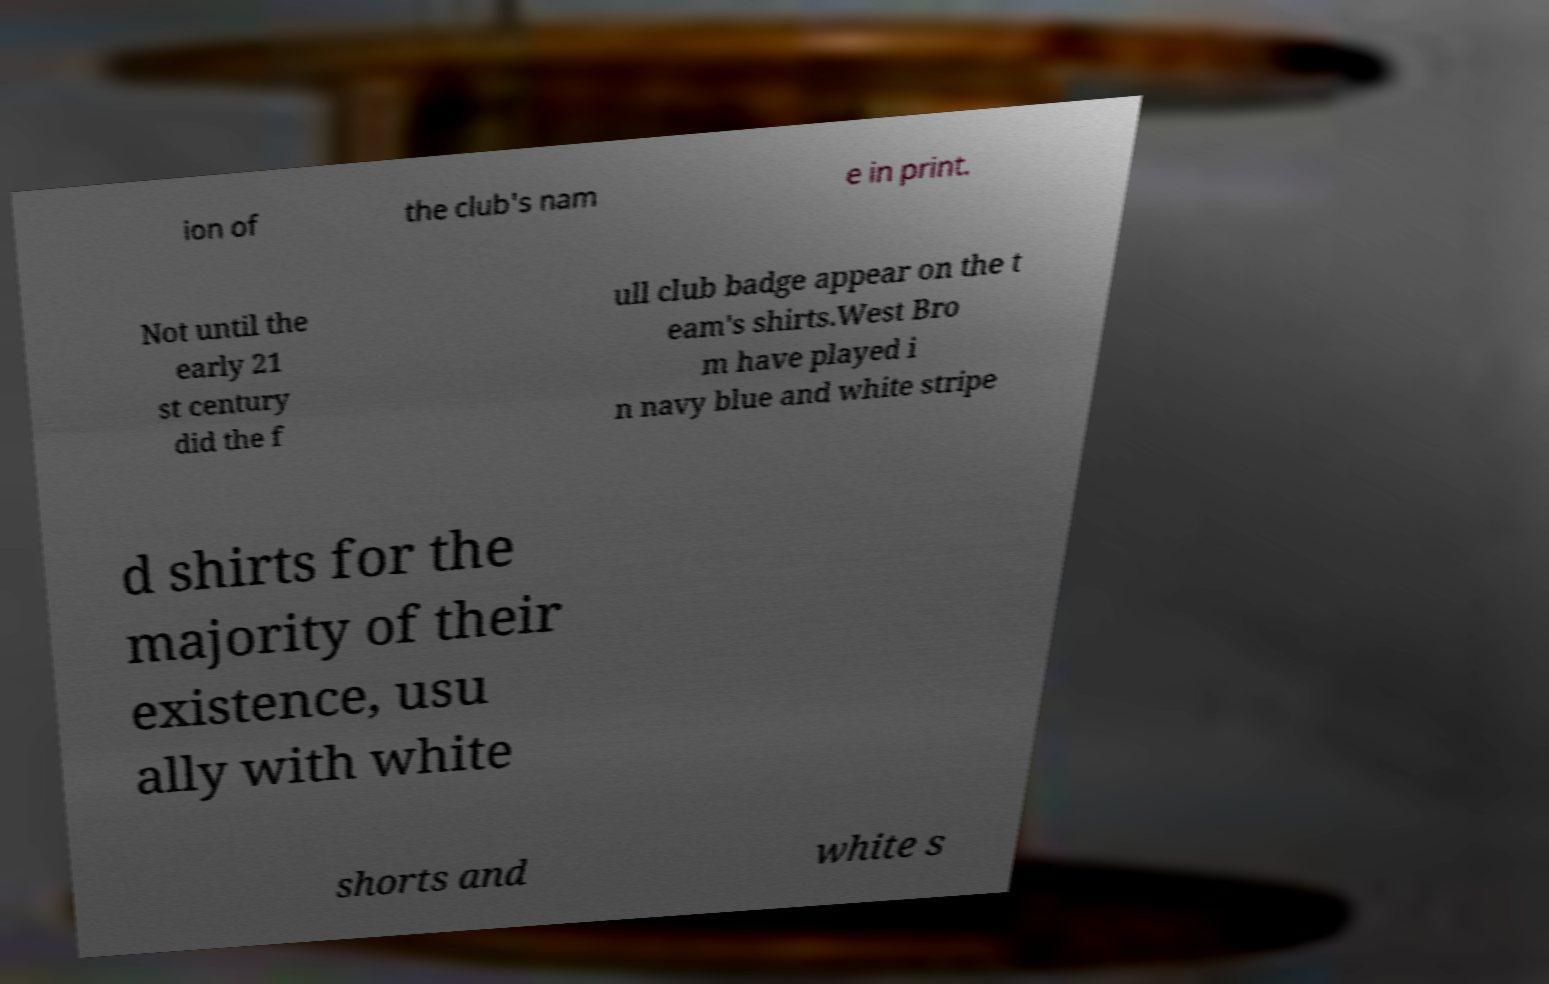Please read and relay the text visible in this image. What does it say? ion of the club's nam e in print. Not until the early 21 st century did the f ull club badge appear on the t eam's shirts.West Bro m have played i n navy blue and white stripe d shirts for the majority of their existence, usu ally with white shorts and white s 